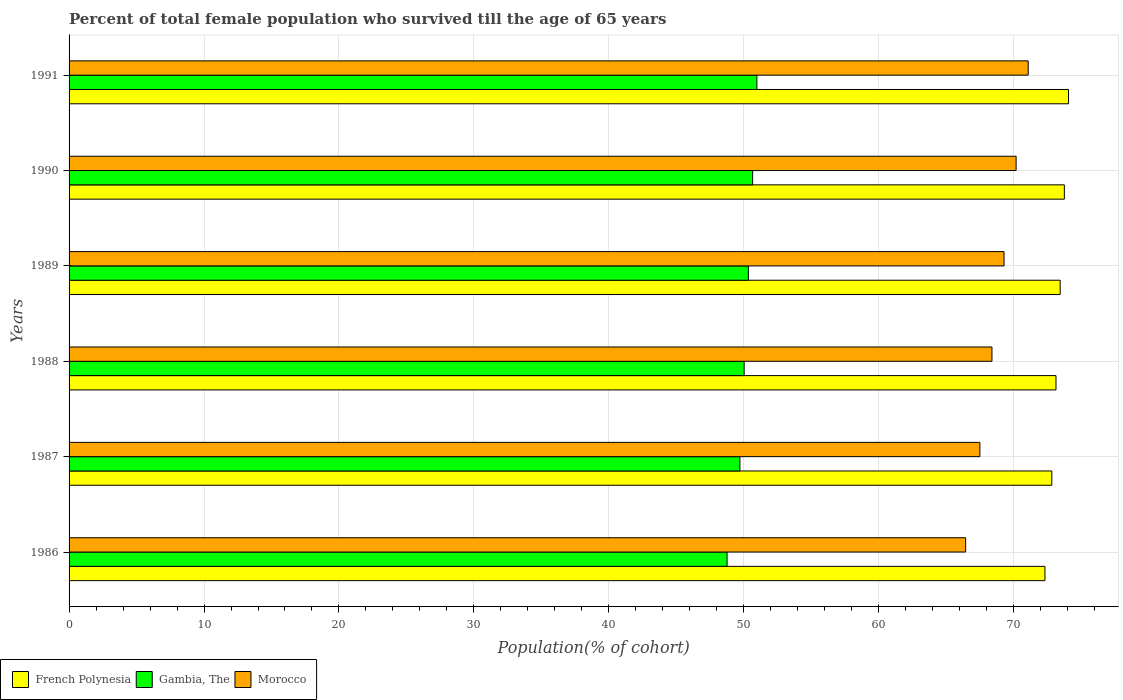How many groups of bars are there?
Provide a short and direct response. 6. Are the number of bars per tick equal to the number of legend labels?
Keep it short and to the point. Yes. What is the percentage of total female population who survived till the age of 65 years in Gambia, The in 1987?
Ensure brevity in your answer.  49.71. Across all years, what is the maximum percentage of total female population who survived till the age of 65 years in French Polynesia?
Give a very brief answer. 74.06. Across all years, what is the minimum percentage of total female population who survived till the age of 65 years in French Polynesia?
Provide a short and direct response. 72.32. In which year was the percentage of total female population who survived till the age of 65 years in Gambia, The minimum?
Keep it short and to the point. 1986. What is the total percentage of total female population who survived till the age of 65 years in Gambia, The in the graph?
Your answer should be compact. 300.46. What is the difference between the percentage of total female population who survived till the age of 65 years in French Polynesia in 1989 and that in 1991?
Make the answer very short. -0.62. What is the difference between the percentage of total female population who survived till the age of 65 years in French Polynesia in 1988 and the percentage of total female population who survived till the age of 65 years in Morocco in 1991?
Offer a terse response. 2.06. What is the average percentage of total female population who survived till the age of 65 years in French Polynesia per year?
Your answer should be very brief. 73.26. In the year 1986, what is the difference between the percentage of total female population who survived till the age of 65 years in Gambia, The and percentage of total female population who survived till the age of 65 years in Morocco?
Keep it short and to the point. -17.68. In how many years, is the percentage of total female population who survived till the age of 65 years in Gambia, The greater than 64 %?
Give a very brief answer. 0. What is the ratio of the percentage of total female population who survived till the age of 65 years in French Polynesia in 1986 to that in 1991?
Your answer should be compact. 0.98. Is the difference between the percentage of total female population who survived till the age of 65 years in Gambia, The in 1986 and 1990 greater than the difference between the percentage of total female population who survived till the age of 65 years in Morocco in 1986 and 1990?
Provide a succinct answer. Yes. What is the difference between the highest and the second highest percentage of total female population who survived till the age of 65 years in Morocco?
Provide a short and direct response. 0.9. What is the difference between the highest and the lowest percentage of total female population who survived till the age of 65 years in Morocco?
Ensure brevity in your answer.  4.64. What does the 2nd bar from the top in 1989 represents?
Offer a terse response. Gambia, The. What does the 3rd bar from the bottom in 1989 represents?
Your response must be concise. Morocco. Are the values on the major ticks of X-axis written in scientific E-notation?
Provide a short and direct response. No. Does the graph contain any zero values?
Keep it short and to the point. No. How many legend labels are there?
Your answer should be very brief. 3. What is the title of the graph?
Provide a short and direct response. Percent of total female population who survived till the age of 65 years. What is the label or title of the X-axis?
Your answer should be compact. Population(% of cohort). What is the label or title of the Y-axis?
Offer a terse response. Years. What is the Population(% of cohort) in French Polynesia in 1986?
Ensure brevity in your answer.  72.32. What is the Population(% of cohort) of Gambia, The in 1986?
Give a very brief answer. 48.76. What is the Population(% of cohort) in Morocco in 1986?
Give a very brief answer. 66.44. What is the Population(% of cohort) in French Polynesia in 1987?
Your answer should be very brief. 72.82. What is the Population(% of cohort) in Gambia, The in 1987?
Provide a succinct answer. 49.71. What is the Population(% of cohort) in Morocco in 1987?
Keep it short and to the point. 67.49. What is the Population(% of cohort) of French Polynesia in 1988?
Your answer should be compact. 73.13. What is the Population(% of cohort) in Gambia, The in 1988?
Offer a terse response. 50.03. What is the Population(% of cohort) of Morocco in 1988?
Your response must be concise. 68.39. What is the Population(% of cohort) of French Polynesia in 1989?
Keep it short and to the point. 73.44. What is the Population(% of cohort) of Gambia, The in 1989?
Make the answer very short. 50.34. What is the Population(% of cohort) in Morocco in 1989?
Keep it short and to the point. 69.28. What is the Population(% of cohort) of French Polynesia in 1990?
Your response must be concise. 73.75. What is the Population(% of cohort) in Gambia, The in 1990?
Give a very brief answer. 50.65. What is the Population(% of cohort) of Morocco in 1990?
Your answer should be compact. 70.18. What is the Population(% of cohort) in French Polynesia in 1991?
Your response must be concise. 74.06. What is the Population(% of cohort) of Gambia, The in 1991?
Give a very brief answer. 50.97. What is the Population(% of cohort) in Morocco in 1991?
Keep it short and to the point. 71.07. Across all years, what is the maximum Population(% of cohort) of French Polynesia?
Make the answer very short. 74.06. Across all years, what is the maximum Population(% of cohort) in Gambia, The?
Provide a succinct answer. 50.97. Across all years, what is the maximum Population(% of cohort) of Morocco?
Offer a terse response. 71.07. Across all years, what is the minimum Population(% of cohort) in French Polynesia?
Ensure brevity in your answer.  72.32. Across all years, what is the minimum Population(% of cohort) in Gambia, The?
Offer a very short reply. 48.76. Across all years, what is the minimum Population(% of cohort) in Morocco?
Offer a very short reply. 66.44. What is the total Population(% of cohort) in French Polynesia in the graph?
Give a very brief answer. 439.53. What is the total Population(% of cohort) in Gambia, The in the graph?
Offer a very short reply. 300.46. What is the total Population(% of cohort) in Morocco in the graph?
Provide a short and direct response. 412.86. What is the difference between the Population(% of cohort) of French Polynesia in 1986 and that in 1987?
Provide a succinct answer. -0.51. What is the difference between the Population(% of cohort) in Gambia, The in 1986 and that in 1987?
Ensure brevity in your answer.  -0.95. What is the difference between the Population(% of cohort) of Morocco in 1986 and that in 1987?
Offer a terse response. -1.06. What is the difference between the Population(% of cohort) of French Polynesia in 1986 and that in 1988?
Offer a terse response. -0.82. What is the difference between the Population(% of cohort) of Gambia, The in 1986 and that in 1988?
Offer a very short reply. -1.27. What is the difference between the Population(% of cohort) of Morocco in 1986 and that in 1988?
Make the answer very short. -1.95. What is the difference between the Population(% of cohort) of French Polynesia in 1986 and that in 1989?
Make the answer very short. -1.13. What is the difference between the Population(% of cohort) of Gambia, The in 1986 and that in 1989?
Ensure brevity in your answer.  -1.58. What is the difference between the Population(% of cohort) of Morocco in 1986 and that in 1989?
Provide a short and direct response. -2.85. What is the difference between the Population(% of cohort) of French Polynesia in 1986 and that in 1990?
Give a very brief answer. -1.44. What is the difference between the Population(% of cohort) of Gambia, The in 1986 and that in 1990?
Your response must be concise. -1.89. What is the difference between the Population(% of cohort) of Morocco in 1986 and that in 1990?
Keep it short and to the point. -3.74. What is the difference between the Population(% of cohort) of French Polynesia in 1986 and that in 1991?
Make the answer very short. -1.75. What is the difference between the Population(% of cohort) of Gambia, The in 1986 and that in 1991?
Provide a succinct answer. -2.21. What is the difference between the Population(% of cohort) in Morocco in 1986 and that in 1991?
Offer a very short reply. -4.64. What is the difference between the Population(% of cohort) in French Polynesia in 1987 and that in 1988?
Offer a terse response. -0.31. What is the difference between the Population(% of cohort) in Gambia, The in 1987 and that in 1988?
Your answer should be compact. -0.31. What is the difference between the Population(% of cohort) in Morocco in 1987 and that in 1988?
Your response must be concise. -0.9. What is the difference between the Population(% of cohort) in French Polynesia in 1987 and that in 1989?
Make the answer very short. -0.62. What is the difference between the Population(% of cohort) in Gambia, The in 1987 and that in 1989?
Give a very brief answer. -0.63. What is the difference between the Population(% of cohort) in Morocco in 1987 and that in 1989?
Offer a terse response. -1.79. What is the difference between the Population(% of cohort) of French Polynesia in 1987 and that in 1990?
Provide a short and direct response. -0.93. What is the difference between the Population(% of cohort) of Gambia, The in 1987 and that in 1990?
Offer a very short reply. -0.94. What is the difference between the Population(% of cohort) of Morocco in 1987 and that in 1990?
Provide a short and direct response. -2.69. What is the difference between the Population(% of cohort) of French Polynesia in 1987 and that in 1991?
Offer a terse response. -1.24. What is the difference between the Population(% of cohort) in Gambia, The in 1987 and that in 1991?
Your answer should be compact. -1.26. What is the difference between the Population(% of cohort) in Morocco in 1987 and that in 1991?
Provide a succinct answer. -3.58. What is the difference between the Population(% of cohort) in French Polynesia in 1988 and that in 1989?
Your response must be concise. -0.31. What is the difference between the Population(% of cohort) in Gambia, The in 1988 and that in 1989?
Offer a very short reply. -0.31. What is the difference between the Population(% of cohort) of Morocco in 1988 and that in 1989?
Your answer should be compact. -0.9. What is the difference between the Population(% of cohort) in French Polynesia in 1988 and that in 1990?
Your answer should be very brief. -0.62. What is the difference between the Population(% of cohort) in Gambia, The in 1988 and that in 1990?
Offer a terse response. -0.63. What is the difference between the Population(% of cohort) of Morocco in 1988 and that in 1990?
Keep it short and to the point. -1.79. What is the difference between the Population(% of cohort) of French Polynesia in 1988 and that in 1991?
Ensure brevity in your answer.  -0.93. What is the difference between the Population(% of cohort) of Gambia, The in 1988 and that in 1991?
Give a very brief answer. -0.94. What is the difference between the Population(% of cohort) of Morocco in 1988 and that in 1991?
Your answer should be very brief. -2.69. What is the difference between the Population(% of cohort) in French Polynesia in 1989 and that in 1990?
Offer a very short reply. -0.31. What is the difference between the Population(% of cohort) of Gambia, The in 1989 and that in 1990?
Offer a very short reply. -0.31. What is the difference between the Population(% of cohort) of Morocco in 1989 and that in 1990?
Provide a short and direct response. -0.9. What is the difference between the Population(% of cohort) of French Polynesia in 1989 and that in 1991?
Offer a terse response. -0.62. What is the difference between the Population(% of cohort) in Gambia, The in 1989 and that in 1991?
Keep it short and to the point. -0.63. What is the difference between the Population(% of cohort) in Morocco in 1989 and that in 1991?
Ensure brevity in your answer.  -1.79. What is the difference between the Population(% of cohort) of French Polynesia in 1990 and that in 1991?
Your response must be concise. -0.31. What is the difference between the Population(% of cohort) of Gambia, The in 1990 and that in 1991?
Offer a terse response. -0.31. What is the difference between the Population(% of cohort) of Morocco in 1990 and that in 1991?
Provide a short and direct response. -0.9. What is the difference between the Population(% of cohort) of French Polynesia in 1986 and the Population(% of cohort) of Gambia, The in 1987?
Offer a very short reply. 22.6. What is the difference between the Population(% of cohort) of French Polynesia in 1986 and the Population(% of cohort) of Morocco in 1987?
Provide a succinct answer. 4.82. What is the difference between the Population(% of cohort) of Gambia, The in 1986 and the Population(% of cohort) of Morocco in 1987?
Provide a short and direct response. -18.73. What is the difference between the Population(% of cohort) of French Polynesia in 1986 and the Population(% of cohort) of Gambia, The in 1988?
Offer a very short reply. 22.29. What is the difference between the Population(% of cohort) of French Polynesia in 1986 and the Population(% of cohort) of Morocco in 1988?
Keep it short and to the point. 3.93. What is the difference between the Population(% of cohort) in Gambia, The in 1986 and the Population(% of cohort) in Morocco in 1988?
Your answer should be compact. -19.63. What is the difference between the Population(% of cohort) in French Polynesia in 1986 and the Population(% of cohort) in Gambia, The in 1989?
Keep it short and to the point. 21.98. What is the difference between the Population(% of cohort) in French Polynesia in 1986 and the Population(% of cohort) in Morocco in 1989?
Provide a succinct answer. 3.03. What is the difference between the Population(% of cohort) in Gambia, The in 1986 and the Population(% of cohort) in Morocco in 1989?
Provide a short and direct response. -20.52. What is the difference between the Population(% of cohort) in French Polynesia in 1986 and the Population(% of cohort) in Gambia, The in 1990?
Keep it short and to the point. 21.66. What is the difference between the Population(% of cohort) of French Polynesia in 1986 and the Population(% of cohort) of Morocco in 1990?
Ensure brevity in your answer.  2.14. What is the difference between the Population(% of cohort) of Gambia, The in 1986 and the Population(% of cohort) of Morocco in 1990?
Offer a terse response. -21.42. What is the difference between the Population(% of cohort) in French Polynesia in 1986 and the Population(% of cohort) in Gambia, The in 1991?
Provide a succinct answer. 21.35. What is the difference between the Population(% of cohort) of French Polynesia in 1986 and the Population(% of cohort) of Morocco in 1991?
Offer a very short reply. 1.24. What is the difference between the Population(% of cohort) in Gambia, The in 1986 and the Population(% of cohort) in Morocco in 1991?
Make the answer very short. -22.31. What is the difference between the Population(% of cohort) in French Polynesia in 1987 and the Population(% of cohort) in Gambia, The in 1988?
Your answer should be very brief. 22.8. What is the difference between the Population(% of cohort) of French Polynesia in 1987 and the Population(% of cohort) of Morocco in 1988?
Provide a short and direct response. 4.44. What is the difference between the Population(% of cohort) in Gambia, The in 1987 and the Population(% of cohort) in Morocco in 1988?
Your answer should be very brief. -18.68. What is the difference between the Population(% of cohort) of French Polynesia in 1987 and the Population(% of cohort) of Gambia, The in 1989?
Offer a very short reply. 22.48. What is the difference between the Population(% of cohort) of French Polynesia in 1987 and the Population(% of cohort) of Morocco in 1989?
Your answer should be very brief. 3.54. What is the difference between the Population(% of cohort) of Gambia, The in 1987 and the Population(% of cohort) of Morocco in 1989?
Provide a short and direct response. -19.57. What is the difference between the Population(% of cohort) of French Polynesia in 1987 and the Population(% of cohort) of Gambia, The in 1990?
Ensure brevity in your answer.  22.17. What is the difference between the Population(% of cohort) of French Polynesia in 1987 and the Population(% of cohort) of Morocco in 1990?
Provide a short and direct response. 2.65. What is the difference between the Population(% of cohort) of Gambia, The in 1987 and the Population(% of cohort) of Morocco in 1990?
Your answer should be compact. -20.47. What is the difference between the Population(% of cohort) in French Polynesia in 1987 and the Population(% of cohort) in Gambia, The in 1991?
Make the answer very short. 21.86. What is the difference between the Population(% of cohort) of French Polynesia in 1987 and the Population(% of cohort) of Morocco in 1991?
Your answer should be compact. 1.75. What is the difference between the Population(% of cohort) in Gambia, The in 1987 and the Population(% of cohort) in Morocco in 1991?
Give a very brief answer. -21.36. What is the difference between the Population(% of cohort) in French Polynesia in 1988 and the Population(% of cohort) in Gambia, The in 1989?
Your answer should be compact. 22.79. What is the difference between the Population(% of cohort) of French Polynesia in 1988 and the Population(% of cohort) of Morocco in 1989?
Your response must be concise. 3.85. What is the difference between the Population(% of cohort) of Gambia, The in 1988 and the Population(% of cohort) of Morocco in 1989?
Give a very brief answer. -19.26. What is the difference between the Population(% of cohort) in French Polynesia in 1988 and the Population(% of cohort) in Gambia, The in 1990?
Offer a terse response. 22.48. What is the difference between the Population(% of cohort) in French Polynesia in 1988 and the Population(% of cohort) in Morocco in 1990?
Provide a succinct answer. 2.96. What is the difference between the Population(% of cohort) of Gambia, The in 1988 and the Population(% of cohort) of Morocco in 1990?
Make the answer very short. -20.15. What is the difference between the Population(% of cohort) in French Polynesia in 1988 and the Population(% of cohort) in Gambia, The in 1991?
Your answer should be very brief. 22.17. What is the difference between the Population(% of cohort) in French Polynesia in 1988 and the Population(% of cohort) in Morocco in 1991?
Provide a succinct answer. 2.06. What is the difference between the Population(% of cohort) in Gambia, The in 1988 and the Population(% of cohort) in Morocco in 1991?
Offer a terse response. -21.05. What is the difference between the Population(% of cohort) in French Polynesia in 1989 and the Population(% of cohort) in Gambia, The in 1990?
Provide a succinct answer. 22.79. What is the difference between the Population(% of cohort) of French Polynesia in 1989 and the Population(% of cohort) of Morocco in 1990?
Ensure brevity in your answer.  3.26. What is the difference between the Population(% of cohort) in Gambia, The in 1989 and the Population(% of cohort) in Morocco in 1990?
Your answer should be compact. -19.84. What is the difference between the Population(% of cohort) in French Polynesia in 1989 and the Population(% of cohort) in Gambia, The in 1991?
Your answer should be very brief. 22.47. What is the difference between the Population(% of cohort) in French Polynesia in 1989 and the Population(% of cohort) in Morocco in 1991?
Offer a terse response. 2.37. What is the difference between the Population(% of cohort) of Gambia, The in 1989 and the Population(% of cohort) of Morocco in 1991?
Make the answer very short. -20.73. What is the difference between the Population(% of cohort) of French Polynesia in 1990 and the Population(% of cohort) of Gambia, The in 1991?
Give a very brief answer. 22.78. What is the difference between the Population(% of cohort) in French Polynesia in 1990 and the Population(% of cohort) in Morocco in 1991?
Make the answer very short. 2.68. What is the difference between the Population(% of cohort) in Gambia, The in 1990 and the Population(% of cohort) in Morocco in 1991?
Keep it short and to the point. -20.42. What is the average Population(% of cohort) of French Polynesia per year?
Offer a terse response. 73.26. What is the average Population(% of cohort) in Gambia, The per year?
Your response must be concise. 50.08. What is the average Population(% of cohort) in Morocco per year?
Provide a succinct answer. 68.81. In the year 1986, what is the difference between the Population(% of cohort) in French Polynesia and Population(% of cohort) in Gambia, The?
Your response must be concise. 23.55. In the year 1986, what is the difference between the Population(% of cohort) in French Polynesia and Population(% of cohort) in Morocco?
Keep it short and to the point. 5.88. In the year 1986, what is the difference between the Population(% of cohort) of Gambia, The and Population(% of cohort) of Morocco?
Your response must be concise. -17.68. In the year 1987, what is the difference between the Population(% of cohort) of French Polynesia and Population(% of cohort) of Gambia, The?
Offer a terse response. 23.11. In the year 1987, what is the difference between the Population(% of cohort) in French Polynesia and Population(% of cohort) in Morocco?
Your answer should be compact. 5.33. In the year 1987, what is the difference between the Population(% of cohort) of Gambia, The and Population(% of cohort) of Morocco?
Keep it short and to the point. -17.78. In the year 1988, what is the difference between the Population(% of cohort) in French Polynesia and Population(% of cohort) in Gambia, The?
Offer a very short reply. 23.11. In the year 1988, what is the difference between the Population(% of cohort) in French Polynesia and Population(% of cohort) in Morocco?
Provide a succinct answer. 4.75. In the year 1988, what is the difference between the Population(% of cohort) of Gambia, The and Population(% of cohort) of Morocco?
Keep it short and to the point. -18.36. In the year 1989, what is the difference between the Population(% of cohort) in French Polynesia and Population(% of cohort) in Gambia, The?
Your response must be concise. 23.1. In the year 1989, what is the difference between the Population(% of cohort) of French Polynesia and Population(% of cohort) of Morocco?
Your response must be concise. 4.16. In the year 1989, what is the difference between the Population(% of cohort) of Gambia, The and Population(% of cohort) of Morocco?
Your answer should be compact. -18.94. In the year 1990, what is the difference between the Population(% of cohort) of French Polynesia and Population(% of cohort) of Gambia, The?
Keep it short and to the point. 23.1. In the year 1990, what is the difference between the Population(% of cohort) in French Polynesia and Population(% of cohort) in Morocco?
Your answer should be compact. 3.57. In the year 1990, what is the difference between the Population(% of cohort) of Gambia, The and Population(% of cohort) of Morocco?
Your answer should be compact. -19.52. In the year 1991, what is the difference between the Population(% of cohort) of French Polynesia and Population(% of cohort) of Gambia, The?
Provide a succinct answer. 23.09. In the year 1991, what is the difference between the Population(% of cohort) in French Polynesia and Population(% of cohort) in Morocco?
Your response must be concise. 2.99. In the year 1991, what is the difference between the Population(% of cohort) of Gambia, The and Population(% of cohort) of Morocco?
Your response must be concise. -20.11. What is the ratio of the Population(% of cohort) of Gambia, The in 1986 to that in 1987?
Ensure brevity in your answer.  0.98. What is the ratio of the Population(% of cohort) in Morocco in 1986 to that in 1987?
Provide a succinct answer. 0.98. What is the ratio of the Population(% of cohort) in French Polynesia in 1986 to that in 1988?
Offer a very short reply. 0.99. What is the ratio of the Population(% of cohort) in Gambia, The in 1986 to that in 1988?
Ensure brevity in your answer.  0.97. What is the ratio of the Population(% of cohort) of Morocco in 1986 to that in 1988?
Your answer should be compact. 0.97. What is the ratio of the Population(% of cohort) of French Polynesia in 1986 to that in 1989?
Offer a very short reply. 0.98. What is the ratio of the Population(% of cohort) of Gambia, The in 1986 to that in 1989?
Your answer should be very brief. 0.97. What is the ratio of the Population(% of cohort) of Morocco in 1986 to that in 1989?
Your answer should be very brief. 0.96. What is the ratio of the Population(% of cohort) in French Polynesia in 1986 to that in 1990?
Your answer should be very brief. 0.98. What is the ratio of the Population(% of cohort) of Gambia, The in 1986 to that in 1990?
Ensure brevity in your answer.  0.96. What is the ratio of the Population(% of cohort) in Morocco in 1986 to that in 1990?
Your response must be concise. 0.95. What is the ratio of the Population(% of cohort) in French Polynesia in 1986 to that in 1991?
Give a very brief answer. 0.98. What is the ratio of the Population(% of cohort) of Gambia, The in 1986 to that in 1991?
Provide a short and direct response. 0.96. What is the ratio of the Population(% of cohort) of Morocco in 1986 to that in 1991?
Provide a short and direct response. 0.93. What is the ratio of the Population(% of cohort) in French Polynesia in 1987 to that in 1988?
Your response must be concise. 1. What is the ratio of the Population(% of cohort) of Gambia, The in 1987 to that in 1988?
Your answer should be compact. 0.99. What is the ratio of the Population(% of cohort) in Morocco in 1987 to that in 1988?
Your answer should be compact. 0.99. What is the ratio of the Population(% of cohort) in French Polynesia in 1987 to that in 1989?
Your answer should be very brief. 0.99. What is the ratio of the Population(% of cohort) of Gambia, The in 1987 to that in 1989?
Provide a succinct answer. 0.99. What is the ratio of the Population(% of cohort) of Morocco in 1987 to that in 1989?
Give a very brief answer. 0.97. What is the ratio of the Population(% of cohort) of French Polynesia in 1987 to that in 1990?
Your answer should be compact. 0.99. What is the ratio of the Population(% of cohort) of Gambia, The in 1987 to that in 1990?
Give a very brief answer. 0.98. What is the ratio of the Population(% of cohort) in Morocco in 1987 to that in 1990?
Your response must be concise. 0.96. What is the ratio of the Population(% of cohort) in French Polynesia in 1987 to that in 1991?
Offer a terse response. 0.98. What is the ratio of the Population(% of cohort) in Gambia, The in 1987 to that in 1991?
Your answer should be compact. 0.98. What is the ratio of the Population(% of cohort) in Morocco in 1987 to that in 1991?
Your answer should be compact. 0.95. What is the ratio of the Population(% of cohort) of French Polynesia in 1988 to that in 1989?
Offer a terse response. 1. What is the ratio of the Population(% of cohort) in Gambia, The in 1988 to that in 1989?
Make the answer very short. 0.99. What is the ratio of the Population(% of cohort) of Morocco in 1988 to that in 1989?
Your response must be concise. 0.99. What is the ratio of the Population(% of cohort) of Gambia, The in 1988 to that in 1990?
Offer a terse response. 0.99. What is the ratio of the Population(% of cohort) of Morocco in 1988 to that in 1990?
Provide a short and direct response. 0.97. What is the ratio of the Population(% of cohort) in French Polynesia in 1988 to that in 1991?
Offer a very short reply. 0.99. What is the ratio of the Population(% of cohort) of Gambia, The in 1988 to that in 1991?
Ensure brevity in your answer.  0.98. What is the ratio of the Population(% of cohort) in Morocco in 1988 to that in 1991?
Provide a short and direct response. 0.96. What is the ratio of the Population(% of cohort) in Morocco in 1989 to that in 1990?
Provide a short and direct response. 0.99. What is the ratio of the Population(% of cohort) of Gambia, The in 1989 to that in 1991?
Your response must be concise. 0.99. What is the ratio of the Population(% of cohort) in Morocco in 1989 to that in 1991?
Keep it short and to the point. 0.97. What is the ratio of the Population(% of cohort) of Gambia, The in 1990 to that in 1991?
Ensure brevity in your answer.  0.99. What is the ratio of the Population(% of cohort) in Morocco in 1990 to that in 1991?
Offer a terse response. 0.99. What is the difference between the highest and the second highest Population(% of cohort) in French Polynesia?
Make the answer very short. 0.31. What is the difference between the highest and the second highest Population(% of cohort) of Gambia, The?
Give a very brief answer. 0.31. What is the difference between the highest and the second highest Population(% of cohort) of Morocco?
Your response must be concise. 0.9. What is the difference between the highest and the lowest Population(% of cohort) in French Polynesia?
Provide a short and direct response. 1.75. What is the difference between the highest and the lowest Population(% of cohort) in Gambia, The?
Provide a succinct answer. 2.21. What is the difference between the highest and the lowest Population(% of cohort) in Morocco?
Make the answer very short. 4.64. 